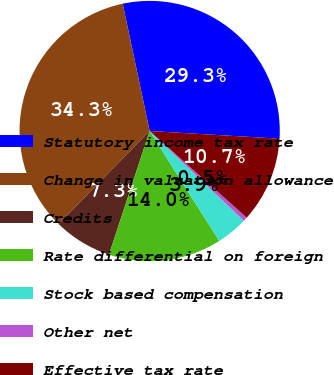Convert chart. <chart><loc_0><loc_0><loc_500><loc_500><pie_chart><fcel>Statutory income tax rate<fcel>Change in valuation allowance<fcel>Credits<fcel>Rate differential on foreign<fcel>Stock based compensation<fcel>Other net<fcel>Effective tax rate<nl><fcel>29.26%<fcel>34.34%<fcel>7.28%<fcel>14.04%<fcel>3.9%<fcel>0.52%<fcel>10.66%<nl></chart> 